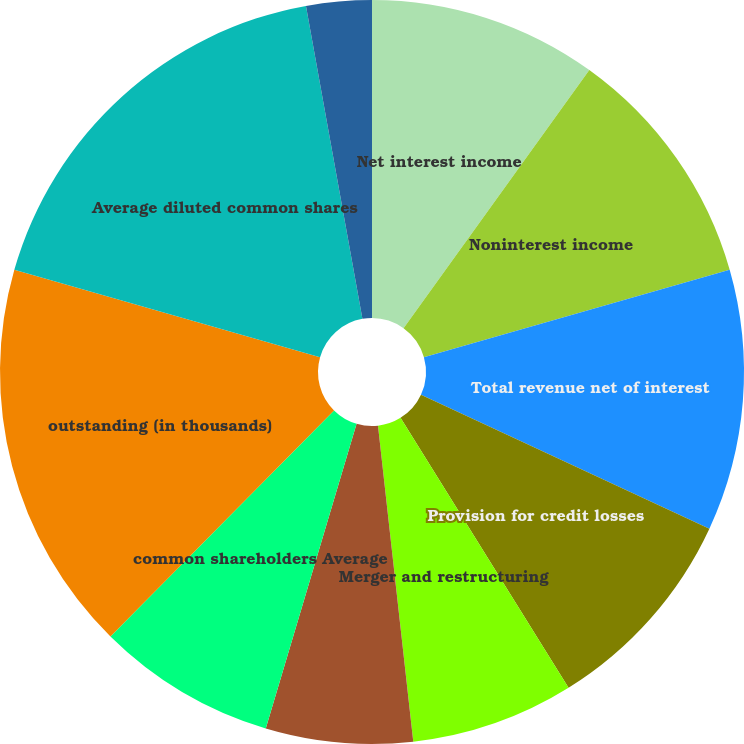Convert chart to OTSL. <chart><loc_0><loc_0><loc_500><loc_500><pie_chart><fcel>Net interest income<fcel>Noninterest income<fcel>Total revenue net of interest<fcel>Provision for credit losses<fcel>Merger and restructuring<fcel>Net income (loss) Net income<fcel>common shareholders Average<fcel>outstanding (in thousands)<fcel>Average diluted common shares<fcel>Total average equity to total<nl><fcel>9.93%<fcel>10.64%<fcel>11.35%<fcel>9.22%<fcel>7.09%<fcel>6.38%<fcel>7.8%<fcel>17.02%<fcel>17.73%<fcel>2.84%<nl></chart> 